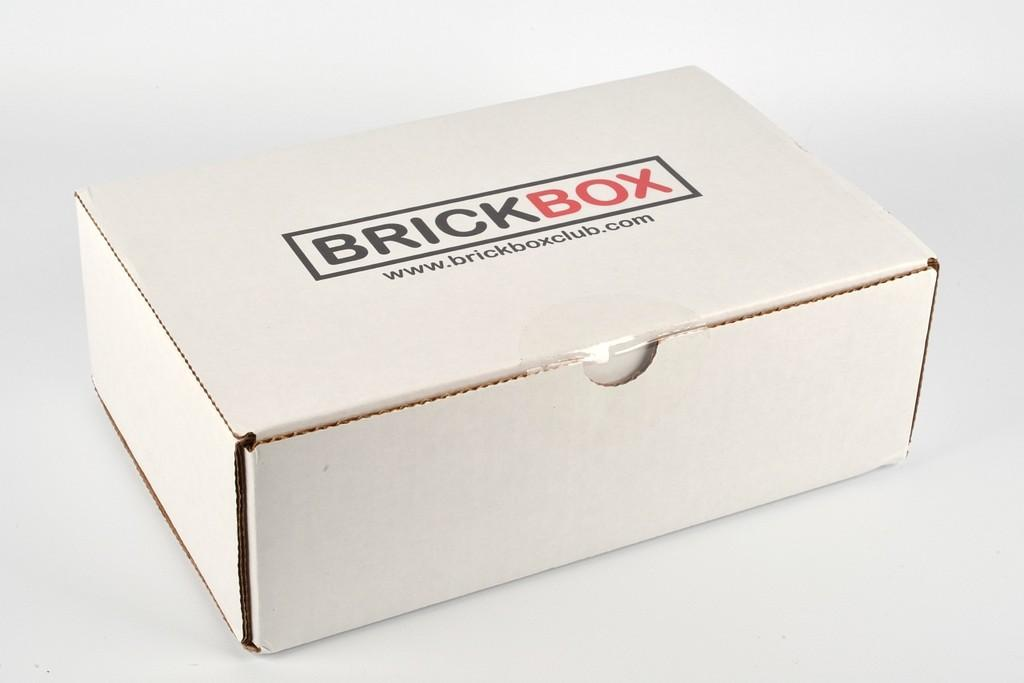<image>
Offer a succinct explanation of the picture presented. A white box labeled BrickBox is printed in black and red. 